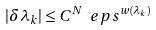<formula> <loc_0><loc_0><loc_500><loc_500>| \delta \lambda _ { k } | \leq C ^ { N } \ e p s ^ { w ( \lambda _ { k } ) }</formula> 